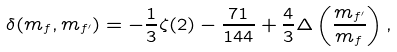Convert formula to latex. <formula><loc_0><loc_0><loc_500><loc_500>\delta ( m _ { f } , m _ { f ^ { \prime } } ) = - \frac { 1 } { 3 } \zeta ( 2 ) - \frac { 7 1 } { 1 4 4 } + \frac { 4 } { 3 } \Delta \left ( \frac { m _ { f ^ { \prime } } } { m _ { f } } \right ) ,</formula> 